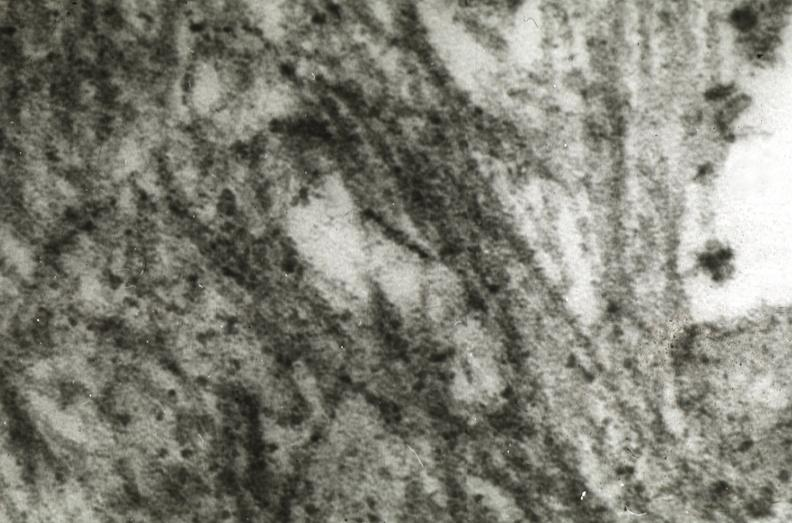where is this area in the body?
Answer the question using a single word or phrase. Heart 